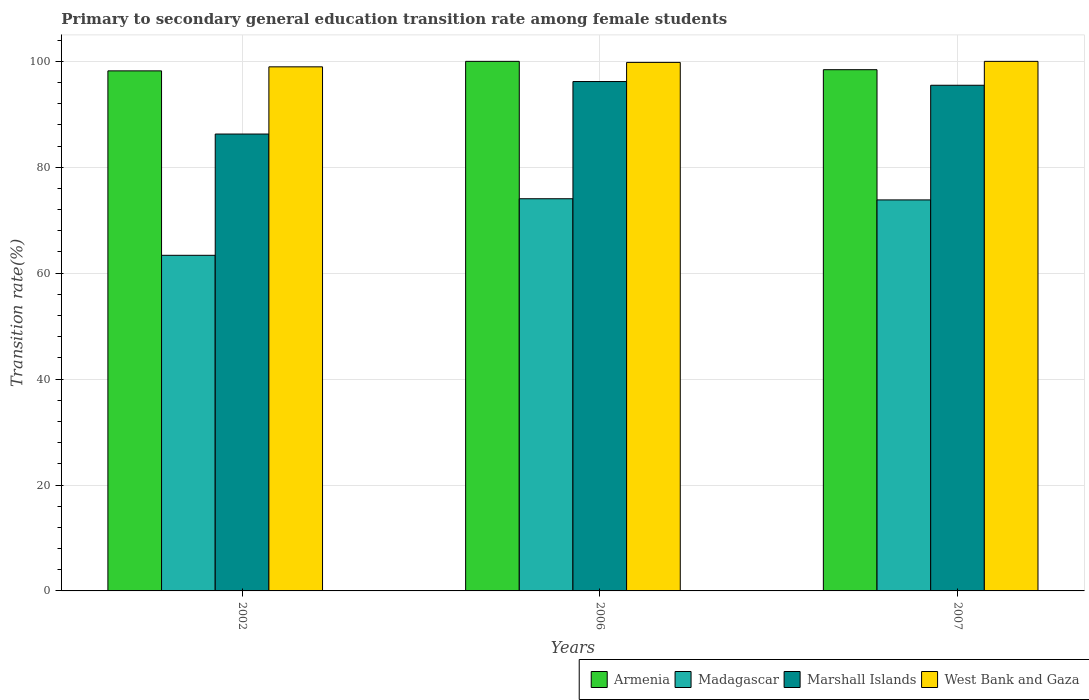Are the number of bars on each tick of the X-axis equal?
Provide a succinct answer. Yes. In how many cases, is the number of bars for a given year not equal to the number of legend labels?
Your answer should be very brief. 0. What is the transition rate in Armenia in 2006?
Your answer should be very brief. 100. Across all years, what is the maximum transition rate in Marshall Islands?
Offer a very short reply. 96.19. Across all years, what is the minimum transition rate in West Bank and Gaza?
Provide a short and direct response. 98.96. In which year was the transition rate in West Bank and Gaza maximum?
Give a very brief answer. 2007. What is the total transition rate in Madagascar in the graph?
Keep it short and to the point. 211.27. What is the difference between the transition rate in West Bank and Gaza in 2002 and that in 2006?
Offer a very short reply. -0.84. What is the difference between the transition rate in Madagascar in 2007 and the transition rate in West Bank and Gaza in 2002?
Your answer should be very brief. -25.13. What is the average transition rate in West Bank and Gaza per year?
Provide a succinct answer. 99.59. In the year 2006, what is the difference between the transition rate in Madagascar and transition rate in Marshall Islands?
Provide a short and direct response. -22.13. What is the ratio of the transition rate in Armenia in 2002 to that in 2006?
Offer a very short reply. 0.98. What is the difference between the highest and the second highest transition rate in Armenia?
Your answer should be very brief. 1.58. What is the difference between the highest and the lowest transition rate in Armenia?
Give a very brief answer. 1.8. In how many years, is the transition rate in Madagascar greater than the average transition rate in Madagascar taken over all years?
Keep it short and to the point. 2. Is the sum of the transition rate in West Bank and Gaza in 2002 and 2007 greater than the maximum transition rate in Madagascar across all years?
Give a very brief answer. Yes. Is it the case that in every year, the sum of the transition rate in Madagascar and transition rate in Armenia is greater than the sum of transition rate in West Bank and Gaza and transition rate in Marshall Islands?
Offer a terse response. No. What does the 4th bar from the left in 2006 represents?
Your answer should be very brief. West Bank and Gaza. What does the 4th bar from the right in 2007 represents?
Ensure brevity in your answer.  Armenia. Is it the case that in every year, the sum of the transition rate in Marshall Islands and transition rate in West Bank and Gaza is greater than the transition rate in Madagascar?
Provide a succinct answer. Yes. How many bars are there?
Provide a short and direct response. 12. Are all the bars in the graph horizontal?
Give a very brief answer. No. How many years are there in the graph?
Ensure brevity in your answer.  3. Does the graph contain any zero values?
Provide a succinct answer. No. What is the title of the graph?
Your answer should be compact. Primary to secondary general education transition rate among female students. Does "Low income" appear as one of the legend labels in the graph?
Make the answer very short. No. What is the label or title of the X-axis?
Your answer should be very brief. Years. What is the label or title of the Y-axis?
Give a very brief answer. Transition rate(%). What is the Transition rate(%) of Armenia in 2002?
Provide a succinct answer. 98.2. What is the Transition rate(%) of Madagascar in 2002?
Provide a succinct answer. 63.37. What is the Transition rate(%) of Marshall Islands in 2002?
Offer a very short reply. 86.27. What is the Transition rate(%) in West Bank and Gaza in 2002?
Provide a succinct answer. 98.96. What is the Transition rate(%) of Madagascar in 2006?
Make the answer very short. 74.06. What is the Transition rate(%) in Marshall Islands in 2006?
Offer a very short reply. 96.19. What is the Transition rate(%) of West Bank and Gaza in 2006?
Offer a very short reply. 99.8. What is the Transition rate(%) in Armenia in 2007?
Ensure brevity in your answer.  98.42. What is the Transition rate(%) in Madagascar in 2007?
Ensure brevity in your answer.  73.84. What is the Transition rate(%) of Marshall Islands in 2007?
Make the answer very short. 95.48. What is the Transition rate(%) of West Bank and Gaza in 2007?
Your answer should be very brief. 100. Across all years, what is the maximum Transition rate(%) of Armenia?
Provide a short and direct response. 100. Across all years, what is the maximum Transition rate(%) of Madagascar?
Make the answer very short. 74.06. Across all years, what is the maximum Transition rate(%) in Marshall Islands?
Your answer should be compact. 96.19. Across all years, what is the maximum Transition rate(%) of West Bank and Gaza?
Your answer should be very brief. 100. Across all years, what is the minimum Transition rate(%) of Armenia?
Make the answer very short. 98.2. Across all years, what is the minimum Transition rate(%) of Madagascar?
Offer a very short reply. 63.37. Across all years, what is the minimum Transition rate(%) in Marshall Islands?
Offer a terse response. 86.27. Across all years, what is the minimum Transition rate(%) in West Bank and Gaza?
Your answer should be compact. 98.96. What is the total Transition rate(%) of Armenia in the graph?
Keep it short and to the point. 296.63. What is the total Transition rate(%) in Madagascar in the graph?
Provide a succinct answer. 211.27. What is the total Transition rate(%) of Marshall Islands in the graph?
Provide a succinct answer. 277.95. What is the total Transition rate(%) of West Bank and Gaza in the graph?
Your answer should be very brief. 298.77. What is the difference between the Transition rate(%) in Armenia in 2002 and that in 2006?
Your answer should be very brief. -1.8. What is the difference between the Transition rate(%) of Madagascar in 2002 and that in 2006?
Give a very brief answer. -10.68. What is the difference between the Transition rate(%) of Marshall Islands in 2002 and that in 2006?
Your answer should be very brief. -9.91. What is the difference between the Transition rate(%) in West Bank and Gaza in 2002 and that in 2006?
Make the answer very short. -0.84. What is the difference between the Transition rate(%) in Armenia in 2002 and that in 2007?
Your response must be concise. -0.22. What is the difference between the Transition rate(%) of Madagascar in 2002 and that in 2007?
Your response must be concise. -10.46. What is the difference between the Transition rate(%) of Marshall Islands in 2002 and that in 2007?
Provide a succinct answer. -9.21. What is the difference between the Transition rate(%) in West Bank and Gaza in 2002 and that in 2007?
Keep it short and to the point. -1.03. What is the difference between the Transition rate(%) in Armenia in 2006 and that in 2007?
Your response must be concise. 1.58. What is the difference between the Transition rate(%) of Madagascar in 2006 and that in 2007?
Your answer should be compact. 0.22. What is the difference between the Transition rate(%) of Marshall Islands in 2006 and that in 2007?
Your answer should be very brief. 0.7. What is the difference between the Transition rate(%) in West Bank and Gaza in 2006 and that in 2007?
Provide a short and direct response. -0.19. What is the difference between the Transition rate(%) in Armenia in 2002 and the Transition rate(%) in Madagascar in 2006?
Make the answer very short. 24.15. What is the difference between the Transition rate(%) in Armenia in 2002 and the Transition rate(%) in Marshall Islands in 2006?
Offer a terse response. 2.02. What is the difference between the Transition rate(%) in Armenia in 2002 and the Transition rate(%) in West Bank and Gaza in 2006?
Give a very brief answer. -1.6. What is the difference between the Transition rate(%) in Madagascar in 2002 and the Transition rate(%) in Marshall Islands in 2006?
Provide a succinct answer. -32.81. What is the difference between the Transition rate(%) in Madagascar in 2002 and the Transition rate(%) in West Bank and Gaza in 2006?
Your answer should be very brief. -36.43. What is the difference between the Transition rate(%) in Marshall Islands in 2002 and the Transition rate(%) in West Bank and Gaza in 2006?
Ensure brevity in your answer.  -13.53. What is the difference between the Transition rate(%) in Armenia in 2002 and the Transition rate(%) in Madagascar in 2007?
Your answer should be compact. 24.37. What is the difference between the Transition rate(%) of Armenia in 2002 and the Transition rate(%) of Marshall Islands in 2007?
Your answer should be very brief. 2.72. What is the difference between the Transition rate(%) of Armenia in 2002 and the Transition rate(%) of West Bank and Gaza in 2007?
Offer a terse response. -1.79. What is the difference between the Transition rate(%) in Madagascar in 2002 and the Transition rate(%) in Marshall Islands in 2007?
Your response must be concise. -32.11. What is the difference between the Transition rate(%) of Madagascar in 2002 and the Transition rate(%) of West Bank and Gaza in 2007?
Your response must be concise. -36.62. What is the difference between the Transition rate(%) in Marshall Islands in 2002 and the Transition rate(%) in West Bank and Gaza in 2007?
Keep it short and to the point. -13.72. What is the difference between the Transition rate(%) of Armenia in 2006 and the Transition rate(%) of Madagascar in 2007?
Ensure brevity in your answer.  26.16. What is the difference between the Transition rate(%) of Armenia in 2006 and the Transition rate(%) of Marshall Islands in 2007?
Your response must be concise. 4.52. What is the difference between the Transition rate(%) in Armenia in 2006 and the Transition rate(%) in West Bank and Gaza in 2007?
Provide a succinct answer. 0. What is the difference between the Transition rate(%) in Madagascar in 2006 and the Transition rate(%) in Marshall Islands in 2007?
Your answer should be compact. -21.43. What is the difference between the Transition rate(%) of Madagascar in 2006 and the Transition rate(%) of West Bank and Gaza in 2007?
Your answer should be very brief. -25.94. What is the difference between the Transition rate(%) in Marshall Islands in 2006 and the Transition rate(%) in West Bank and Gaza in 2007?
Provide a succinct answer. -3.81. What is the average Transition rate(%) of Armenia per year?
Ensure brevity in your answer.  98.88. What is the average Transition rate(%) in Madagascar per year?
Provide a succinct answer. 70.42. What is the average Transition rate(%) in Marshall Islands per year?
Your response must be concise. 92.65. What is the average Transition rate(%) of West Bank and Gaza per year?
Keep it short and to the point. 99.59. In the year 2002, what is the difference between the Transition rate(%) of Armenia and Transition rate(%) of Madagascar?
Your answer should be very brief. 34.83. In the year 2002, what is the difference between the Transition rate(%) in Armenia and Transition rate(%) in Marshall Islands?
Offer a very short reply. 11.93. In the year 2002, what is the difference between the Transition rate(%) in Armenia and Transition rate(%) in West Bank and Gaza?
Provide a short and direct response. -0.76. In the year 2002, what is the difference between the Transition rate(%) of Madagascar and Transition rate(%) of Marshall Islands?
Offer a terse response. -22.9. In the year 2002, what is the difference between the Transition rate(%) of Madagascar and Transition rate(%) of West Bank and Gaza?
Offer a terse response. -35.59. In the year 2002, what is the difference between the Transition rate(%) of Marshall Islands and Transition rate(%) of West Bank and Gaza?
Your answer should be very brief. -12.69. In the year 2006, what is the difference between the Transition rate(%) in Armenia and Transition rate(%) in Madagascar?
Give a very brief answer. 25.94. In the year 2006, what is the difference between the Transition rate(%) in Armenia and Transition rate(%) in Marshall Islands?
Ensure brevity in your answer.  3.81. In the year 2006, what is the difference between the Transition rate(%) of Armenia and Transition rate(%) of West Bank and Gaza?
Give a very brief answer. 0.2. In the year 2006, what is the difference between the Transition rate(%) in Madagascar and Transition rate(%) in Marshall Islands?
Your response must be concise. -22.13. In the year 2006, what is the difference between the Transition rate(%) in Madagascar and Transition rate(%) in West Bank and Gaza?
Keep it short and to the point. -25.75. In the year 2006, what is the difference between the Transition rate(%) of Marshall Islands and Transition rate(%) of West Bank and Gaza?
Make the answer very short. -3.62. In the year 2007, what is the difference between the Transition rate(%) in Armenia and Transition rate(%) in Madagascar?
Give a very brief answer. 24.59. In the year 2007, what is the difference between the Transition rate(%) of Armenia and Transition rate(%) of Marshall Islands?
Offer a terse response. 2.94. In the year 2007, what is the difference between the Transition rate(%) in Armenia and Transition rate(%) in West Bank and Gaza?
Your answer should be very brief. -1.57. In the year 2007, what is the difference between the Transition rate(%) of Madagascar and Transition rate(%) of Marshall Islands?
Your answer should be very brief. -21.65. In the year 2007, what is the difference between the Transition rate(%) of Madagascar and Transition rate(%) of West Bank and Gaza?
Keep it short and to the point. -26.16. In the year 2007, what is the difference between the Transition rate(%) of Marshall Islands and Transition rate(%) of West Bank and Gaza?
Your answer should be very brief. -4.51. What is the ratio of the Transition rate(%) in Armenia in 2002 to that in 2006?
Offer a terse response. 0.98. What is the ratio of the Transition rate(%) of Madagascar in 2002 to that in 2006?
Provide a short and direct response. 0.86. What is the ratio of the Transition rate(%) of Marshall Islands in 2002 to that in 2006?
Make the answer very short. 0.9. What is the ratio of the Transition rate(%) of West Bank and Gaza in 2002 to that in 2006?
Your response must be concise. 0.99. What is the ratio of the Transition rate(%) in Armenia in 2002 to that in 2007?
Your answer should be very brief. 1. What is the ratio of the Transition rate(%) in Madagascar in 2002 to that in 2007?
Provide a succinct answer. 0.86. What is the ratio of the Transition rate(%) in Marshall Islands in 2002 to that in 2007?
Your answer should be compact. 0.9. What is the ratio of the Transition rate(%) in West Bank and Gaza in 2002 to that in 2007?
Your response must be concise. 0.99. What is the ratio of the Transition rate(%) of Madagascar in 2006 to that in 2007?
Ensure brevity in your answer.  1. What is the ratio of the Transition rate(%) in Marshall Islands in 2006 to that in 2007?
Give a very brief answer. 1.01. What is the difference between the highest and the second highest Transition rate(%) of Armenia?
Your answer should be compact. 1.58. What is the difference between the highest and the second highest Transition rate(%) in Madagascar?
Your answer should be very brief. 0.22. What is the difference between the highest and the second highest Transition rate(%) of Marshall Islands?
Keep it short and to the point. 0.7. What is the difference between the highest and the second highest Transition rate(%) in West Bank and Gaza?
Keep it short and to the point. 0.19. What is the difference between the highest and the lowest Transition rate(%) in Armenia?
Offer a terse response. 1.8. What is the difference between the highest and the lowest Transition rate(%) of Madagascar?
Make the answer very short. 10.68. What is the difference between the highest and the lowest Transition rate(%) in Marshall Islands?
Provide a short and direct response. 9.91. What is the difference between the highest and the lowest Transition rate(%) of West Bank and Gaza?
Provide a succinct answer. 1.03. 